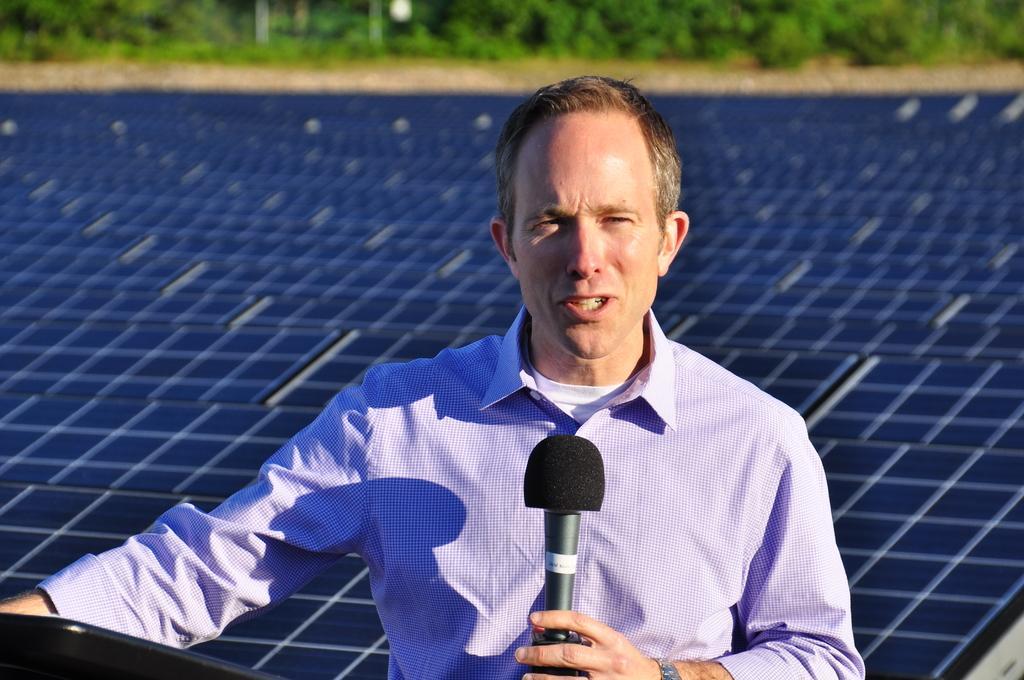How would you summarize this image in a sentence or two? On the background we can see plants. Here we can see one man holding a mike in hand and talking and it seems like a sunny day. 